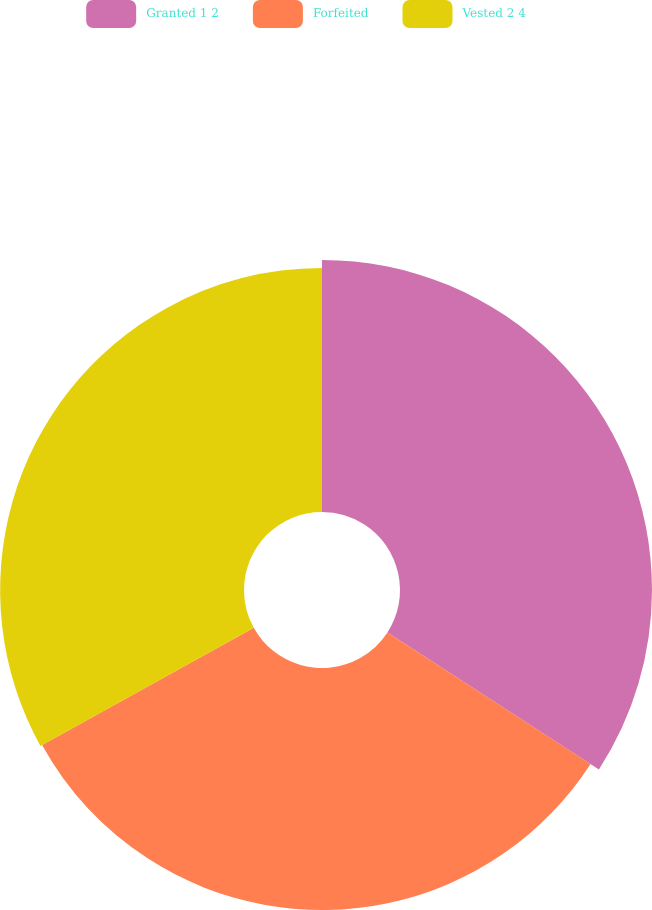Convert chart to OTSL. <chart><loc_0><loc_0><loc_500><loc_500><pie_chart><fcel>Granted 1 2<fcel>Forfeited<fcel>Vested 2 4<nl><fcel>34.15%<fcel>32.8%<fcel>33.05%<nl></chart> 